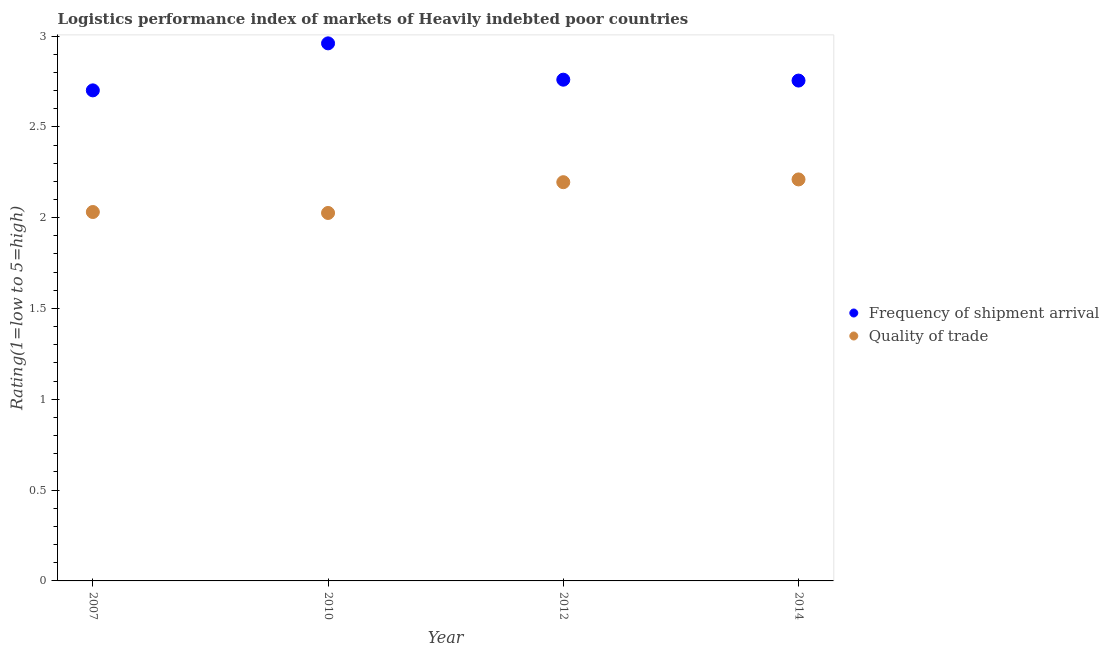What is the lpi quality of trade in 2014?
Provide a short and direct response. 2.21. Across all years, what is the maximum lpi quality of trade?
Offer a terse response. 2.21. Across all years, what is the minimum lpi quality of trade?
Your answer should be compact. 2.03. In which year was the lpi quality of trade maximum?
Keep it short and to the point. 2014. What is the total lpi quality of trade in the graph?
Ensure brevity in your answer.  8.46. What is the difference between the lpi quality of trade in 2007 and that in 2012?
Your answer should be very brief. -0.16. What is the difference between the lpi quality of trade in 2010 and the lpi of frequency of shipment arrival in 2012?
Your answer should be compact. -0.73. What is the average lpi quality of trade per year?
Offer a very short reply. 2.12. In the year 2012, what is the difference between the lpi of frequency of shipment arrival and lpi quality of trade?
Your answer should be very brief. 0.56. In how many years, is the lpi quality of trade greater than 1.2?
Provide a succinct answer. 4. What is the ratio of the lpi of frequency of shipment arrival in 2012 to that in 2014?
Your answer should be very brief. 1. Is the lpi quality of trade in 2012 less than that in 2014?
Your answer should be compact. Yes. What is the difference between the highest and the second highest lpi of frequency of shipment arrival?
Provide a succinct answer. 0.2. What is the difference between the highest and the lowest lpi of frequency of shipment arrival?
Your answer should be very brief. 0.26. In how many years, is the lpi of frequency of shipment arrival greater than the average lpi of frequency of shipment arrival taken over all years?
Ensure brevity in your answer.  1. Is the lpi quality of trade strictly greater than the lpi of frequency of shipment arrival over the years?
Your answer should be compact. No. How many years are there in the graph?
Ensure brevity in your answer.  4. Does the graph contain grids?
Your answer should be very brief. No. Where does the legend appear in the graph?
Offer a very short reply. Center right. How many legend labels are there?
Offer a terse response. 2. How are the legend labels stacked?
Keep it short and to the point. Vertical. What is the title of the graph?
Provide a short and direct response. Logistics performance index of markets of Heavily indebted poor countries. What is the label or title of the Y-axis?
Your response must be concise. Rating(1=low to 5=high). What is the Rating(1=low to 5=high) in Frequency of shipment arrival in 2007?
Your answer should be very brief. 2.7. What is the Rating(1=low to 5=high) of Quality of trade in 2007?
Provide a short and direct response. 2.03. What is the Rating(1=low to 5=high) of Frequency of shipment arrival in 2010?
Provide a succinct answer. 2.96. What is the Rating(1=low to 5=high) of Quality of trade in 2010?
Give a very brief answer. 2.03. What is the Rating(1=low to 5=high) of Frequency of shipment arrival in 2012?
Your answer should be compact. 2.76. What is the Rating(1=low to 5=high) in Quality of trade in 2012?
Make the answer very short. 2.2. What is the Rating(1=low to 5=high) in Frequency of shipment arrival in 2014?
Your response must be concise. 2.75. What is the Rating(1=low to 5=high) in Quality of trade in 2014?
Provide a succinct answer. 2.21. Across all years, what is the maximum Rating(1=low to 5=high) in Frequency of shipment arrival?
Your answer should be very brief. 2.96. Across all years, what is the maximum Rating(1=low to 5=high) in Quality of trade?
Provide a succinct answer. 2.21. Across all years, what is the minimum Rating(1=low to 5=high) in Frequency of shipment arrival?
Make the answer very short. 2.7. Across all years, what is the minimum Rating(1=low to 5=high) in Quality of trade?
Your response must be concise. 2.03. What is the total Rating(1=low to 5=high) in Frequency of shipment arrival in the graph?
Ensure brevity in your answer.  11.18. What is the total Rating(1=low to 5=high) of Quality of trade in the graph?
Offer a very short reply. 8.46. What is the difference between the Rating(1=low to 5=high) in Frequency of shipment arrival in 2007 and that in 2010?
Make the answer very short. -0.26. What is the difference between the Rating(1=low to 5=high) in Quality of trade in 2007 and that in 2010?
Provide a short and direct response. 0.01. What is the difference between the Rating(1=low to 5=high) of Frequency of shipment arrival in 2007 and that in 2012?
Make the answer very short. -0.06. What is the difference between the Rating(1=low to 5=high) in Quality of trade in 2007 and that in 2012?
Keep it short and to the point. -0.16. What is the difference between the Rating(1=low to 5=high) of Frequency of shipment arrival in 2007 and that in 2014?
Your response must be concise. -0.05. What is the difference between the Rating(1=low to 5=high) in Quality of trade in 2007 and that in 2014?
Your response must be concise. -0.18. What is the difference between the Rating(1=low to 5=high) in Quality of trade in 2010 and that in 2012?
Provide a short and direct response. -0.17. What is the difference between the Rating(1=low to 5=high) of Frequency of shipment arrival in 2010 and that in 2014?
Provide a short and direct response. 0.2. What is the difference between the Rating(1=low to 5=high) of Quality of trade in 2010 and that in 2014?
Ensure brevity in your answer.  -0.18. What is the difference between the Rating(1=low to 5=high) in Frequency of shipment arrival in 2012 and that in 2014?
Offer a terse response. 0. What is the difference between the Rating(1=low to 5=high) of Quality of trade in 2012 and that in 2014?
Provide a succinct answer. -0.02. What is the difference between the Rating(1=low to 5=high) in Frequency of shipment arrival in 2007 and the Rating(1=low to 5=high) in Quality of trade in 2010?
Provide a succinct answer. 0.68. What is the difference between the Rating(1=low to 5=high) of Frequency of shipment arrival in 2007 and the Rating(1=low to 5=high) of Quality of trade in 2012?
Give a very brief answer. 0.51. What is the difference between the Rating(1=low to 5=high) of Frequency of shipment arrival in 2007 and the Rating(1=low to 5=high) of Quality of trade in 2014?
Offer a terse response. 0.49. What is the difference between the Rating(1=low to 5=high) in Frequency of shipment arrival in 2010 and the Rating(1=low to 5=high) in Quality of trade in 2012?
Give a very brief answer. 0.76. What is the difference between the Rating(1=low to 5=high) in Frequency of shipment arrival in 2010 and the Rating(1=low to 5=high) in Quality of trade in 2014?
Offer a terse response. 0.75. What is the difference between the Rating(1=low to 5=high) in Frequency of shipment arrival in 2012 and the Rating(1=low to 5=high) in Quality of trade in 2014?
Provide a short and direct response. 0.55. What is the average Rating(1=low to 5=high) in Frequency of shipment arrival per year?
Offer a terse response. 2.79. What is the average Rating(1=low to 5=high) in Quality of trade per year?
Offer a very short reply. 2.12. In the year 2007, what is the difference between the Rating(1=low to 5=high) of Frequency of shipment arrival and Rating(1=low to 5=high) of Quality of trade?
Give a very brief answer. 0.67. In the year 2010, what is the difference between the Rating(1=low to 5=high) in Frequency of shipment arrival and Rating(1=low to 5=high) in Quality of trade?
Give a very brief answer. 0.93. In the year 2012, what is the difference between the Rating(1=low to 5=high) of Frequency of shipment arrival and Rating(1=low to 5=high) of Quality of trade?
Provide a succinct answer. 0.56. In the year 2014, what is the difference between the Rating(1=low to 5=high) in Frequency of shipment arrival and Rating(1=low to 5=high) in Quality of trade?
Offer a very short reply. 0.54. What is the ratio of the Rating(1=low to 5=high) of Frequency of shipment arrival in 2007 to that in 2010?
Offer a very short reply. 0.91. What is the ratio of the Rating(1=low to 5=high) of Frequency of shipment arrival in 2007 to that in 2012?
Make the answer very short. 0.98. What is the ratio of the Rating(1=low to 5=high) of Quality of trade in 2007 to that in 2012?
Make the answer very short. 0.93. What is the ratio of the Rating(1=low to 5=high) of Frequency of shipment arrival in 2007 to that in 2014?
Make the answer very short. 0.98. What is the ratio of the Rating(1=low to 5=high) in Quality of trade in 2007 to that in 2014?
Provide a short and direct response. 0.92. What is the ratio of the Rating(1=low to 5=high) in Frequency of shipment arrival in 2010 to that in 2012?
Ensure brevity in your answer.  1.07. What is the ratio of the Rating(1=low to 5=high) of Quality of trade in 2010 to that in 2012?
Offer a terse response. 0.92. What is the ratio of the Rating(1=low to 5=high) of Frequency of shipment arrival in 2010 to that in 2014?
Your answer should be compact. 1.07. What is the ratio of the Rating(1=low to 5=high) in Quality of trade in 2010 to that in 2014?
Your answer should be compact. 0.92. What is the ratio of the Rating(1=low to 5=high) of Quality of trade in 2012 to that in 2014?
Give a very brief answer. 0.99. What is the difference between the highest and the second highest Rating(1=low to 5=high) in Quality of trade?
Your response must be concise. 0.02. What is the difference between the highest and the lowest Rating(1=low to 5=high) of Frequency of shipment arrival?
Give a very brief answer. 0.26. What is the difference between the highest and the lowest Rating(1=low to 5=high) in Quality of trade?
Provide a succinct answer. 0.18. 